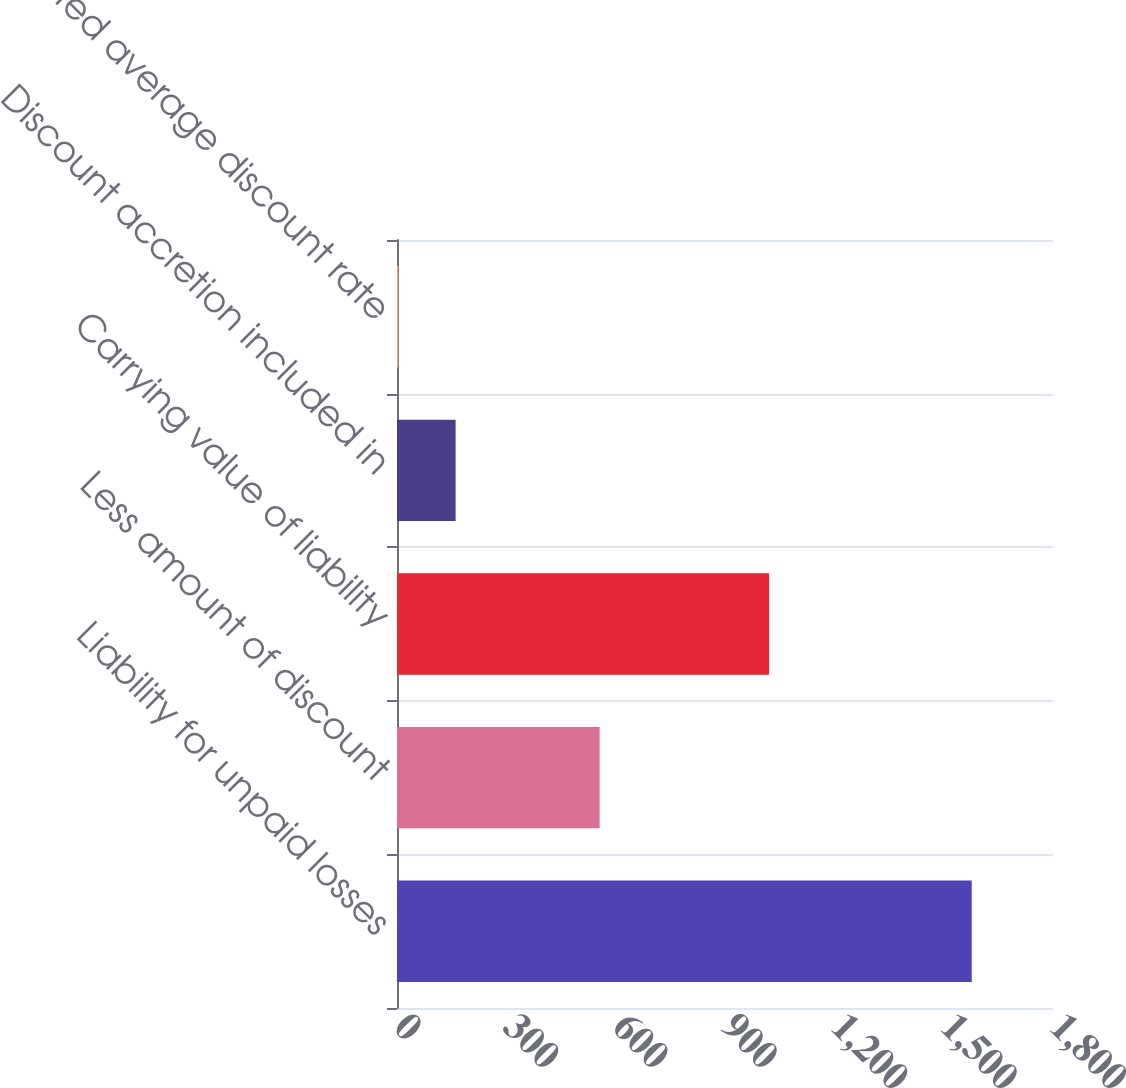Convert chart to OTSL. <chart><loc_0><loc_0><loc_500><loc_500><bar_chart><fcel>Liability for unpaid losses<fcel>Less amount of discount<fcel>Carrying value of liability<fcel>Discount accretion included in<fcel>Weighted average discount rate<nl><fcel>1577<fcel>556<fcel>1021<fcel>160.85<fcel>3.5<nl></chart> 